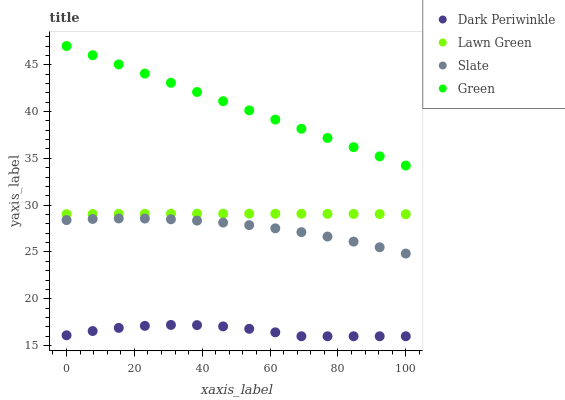Does Dark Periwinkle have the minimum area under the curve?
Answer yes or no. Yes. Does Green have the maximum area under the curve?
Answer yes or no. Yes. Does Slate have the minimum area under the curve?
Answer yes or no. No. Does Slate have the maximum area under the curve?
Answer yes or no. No. Is Green the smoothest?
Answer yes or no. Yes. Is Dark Periwinkle the roughest?
Answer yes or no. Yes. Is Slate the smoothest?
Answer yes or no. No. Is Slate the roughest?
Answer yes or no. No. Does Dark Periwinkle have the lowest value?
Answer yes or no. Yes. Does Slate have the lowest value?
Answer yes or no. No. Does Green have the highest value?
Answer yes or no. Yes. Does Slate have the highest value?
Answer yes or no. No. Is Dark Periwinkle less than Lawn Green?
Answer yes or no. Yes. Is Green greater than Dark Periwinkle?
Answer yes or no. Yes. Does Dark Periwinkle intersect Lawn Green?
Answer yes or no. No. 